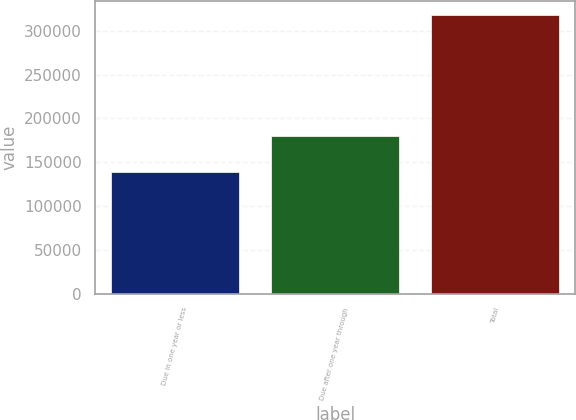Convert chart to OTSL. <chart><loc_0><loc_0><loc_500><loc_500><bar_chart><fcel>Due in one year or less<fcel>Due after one year through<fcel>Total<nl><fcel>138515<fcel>179883<fcel>318398<nl></chart> 